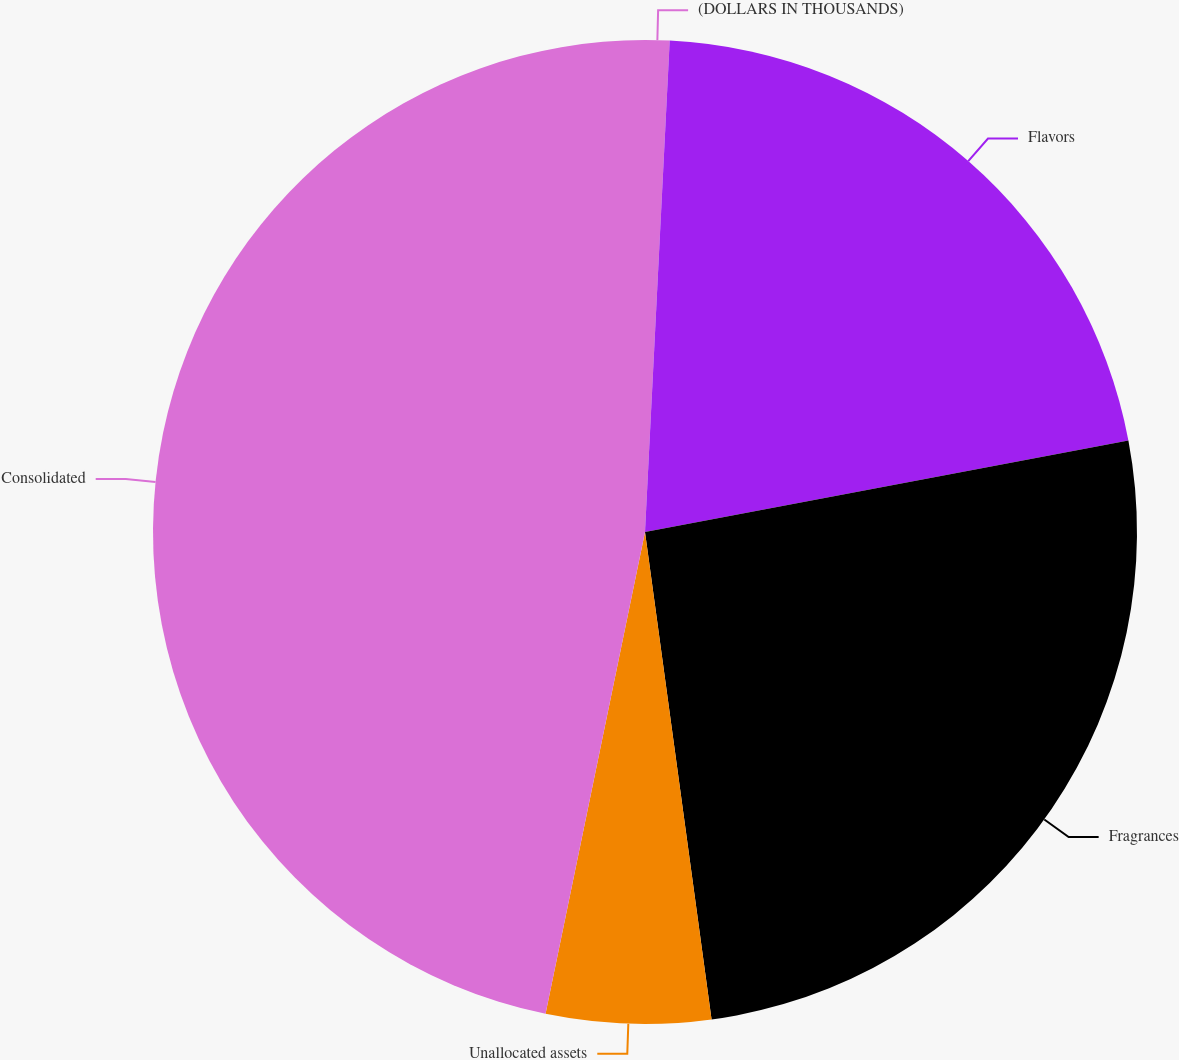Convert chart to OTSL. <chart><loc_0><loc_0><loc_500><loc_500><pie_chart><fcel>(DOLLARS IN THOUSANDS)<fcel>Flavors<fcel>Fragrances<fcel>Unallocated assets<fcel>Consolidated<nl><fcel>0.8%<fcel>21.22%<fcel>25.82%<fcel>5.4%<fcel>46.76%<nl></chart> 